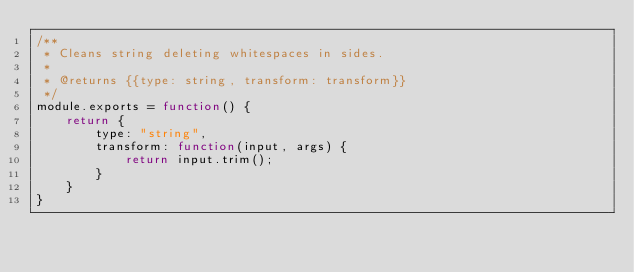<code> <loc_0><loc_0><loc_500><loc_500><_JavaScript_>/**
 * Cleans string deleting whitespaces in sides.
 *
 * @returns {{type: string, transform: transform}}
 */
module.exports = function() {
    return {
        type: "string",
        transform: function(input, args) {
            return input.trim();
        }
    }
}</code> 